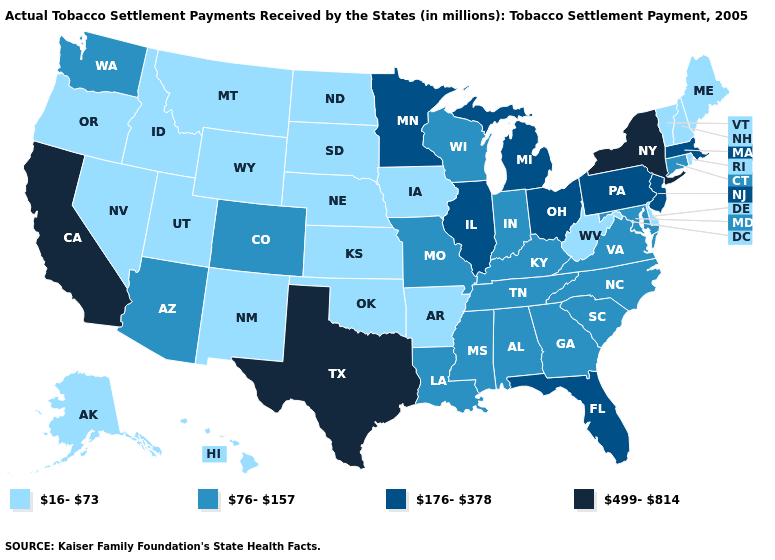Among the states that border Indiana , does Illinois have the lowest value?
Answer briefly. No. How many symbols are there in the legend?
Concise answer only. 4. Does the map have missing data?
Answer briefly. No. Among the states that border New Jersey , which have the highest value?
Write a very short answer. New York. Does the map have missing data?
Answer briefly. No. Does the map have missing data?
Concise answer only. No. Name the states that have a value in the range 16-73?
Be succinct. Alaska, Arkansas, Delaware, Hawaii, Idaho, Iowa, Kansas, Maine, Montana, Nebraska, Nevada, New Hampshire, New Mexico, North Dakota, Oklahoma, Oregon, Rhode Island, South Dakota, Utah, Vermont, West Virginia, Wyoming. What is the value of Hawaii?
Give a very brief answer. 16-73. Name the states that have a value in the range 499-814?
Concise answer only. California, New York, Texas. Name the states that have a value in the range 16-73?
Concise answer only. Alaska, Arkansas, Delaware, Hawaii, Idaho, Iowa, Kansas, Maine, Montana, Nebraska, Nevada, New Hampshire, New Mexico, North Dakota, Oklahoma, Oregon, Rhode Island, South Dakota, Utah, Vermont, West Virginia, Wyoming. Name the states that have a value in the range 76-157?
Concise answer only. Alabama, Arizona, Colorado, Connecticut, Georgia, Indiana, Kentucky, Louisiana, Maryland, Mississippi, Missouri, North Carolina, South Carolina, Tennessee, Virginia, Washington, Wisconsin. Name the states that have a value in the range 499-814?
Answer briefly. California, New York, Texas. Which states have the lowest value in the MidWest?
Answer briefly. Iowa, Kansas, Nebraska, North Dakota, South Dakota. What is the lowest value in the Northeast?
Answer briefly. 16-73. 